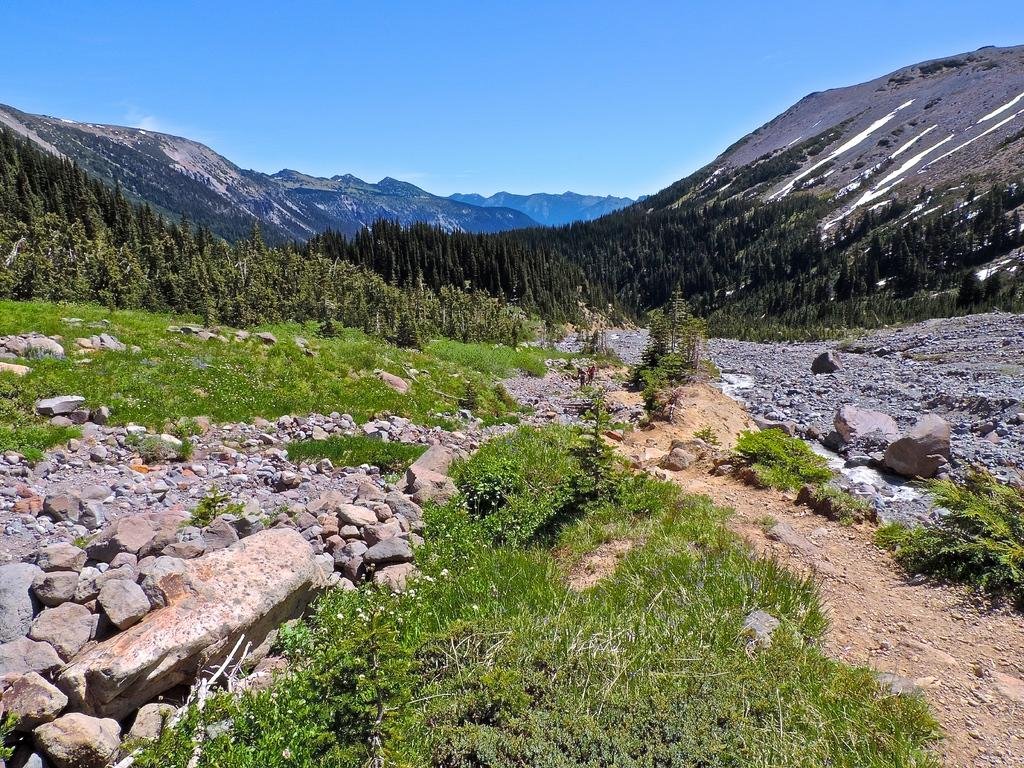What type of vegetation can be seen in the image? There are many trees, plants, and grass in the image. What type of terrain is visible in the image? There are stones in the image, which suggests a rocky or uneven terrain. What can be seen in the background of the image? There are mountains in the background of the image. What is visible at the top of the image? The sky is visible at the top of the image. What type of record can be seen being played on a turntable in the image? There is no turntable or record present in the image; it features a natural landscape with trees, plants, grass, stones, mountains, and sky. 